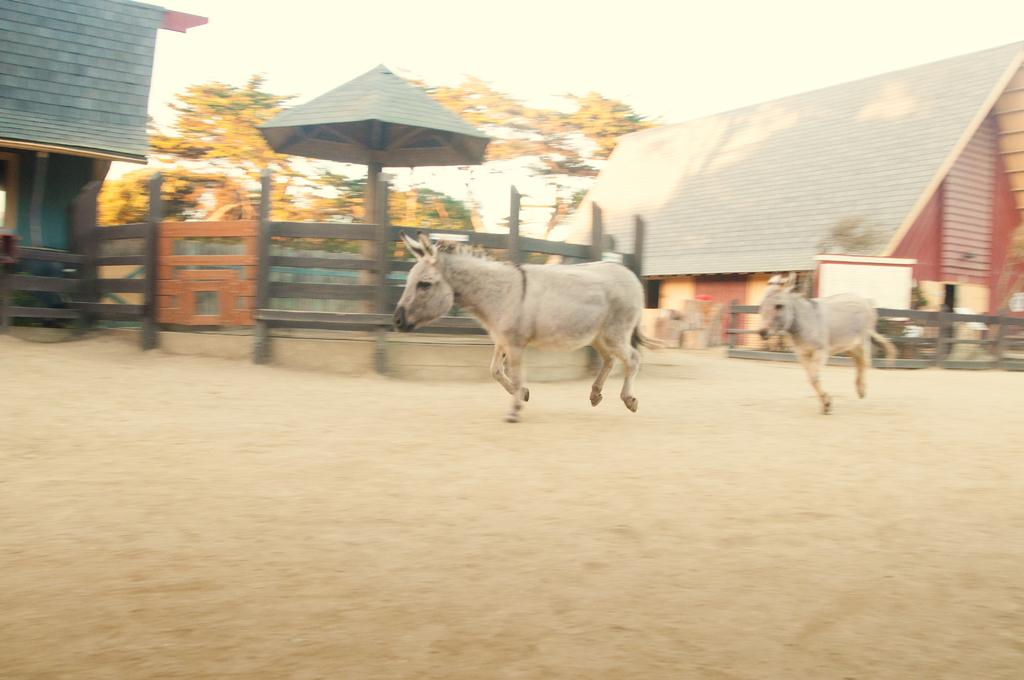What are the two animals doing in the image? The two animals are running on the ground. What can be seen in the background of the image? There are houses and trees visible in the background of the image. What type of fences do the houses have? The houses have wooden fences. What type of cream can be seen on the snail in the image? There is no snail or cream present in the image. What type of tool is the animal using to dig in the image? There is no tool or digging activity depicted in the image. 